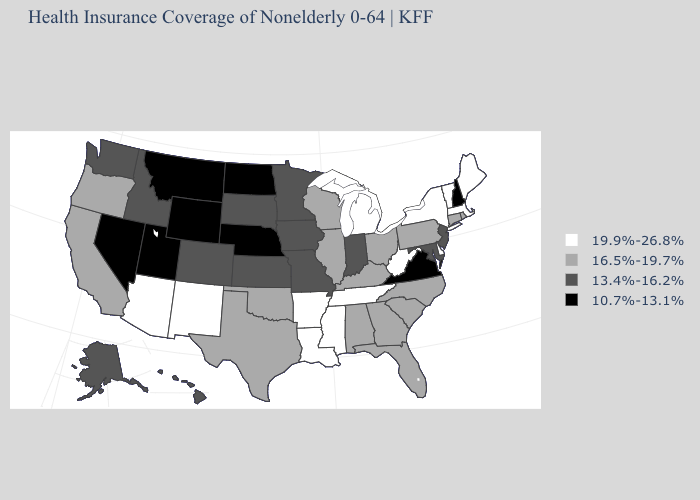What is the value of Ohio?
Write a very short answer. 16.5%-19.7%. Among the states that border Louisiana , does Arkansas have the highest value?
Short answer required. Yes. Does Kansas have the lowest value in the USA?
Answer briefly. No. What is the highest value in the USA?
Quick response, please. 19.9%-26.8%. What is the value of Virginia?
Give a very brief answer. 10.7%-13.1%. Among the states that border Massachusetts , which have the highest value?
Keep it brief. New York, Vermont. What is the value of Alabama?
Concise answer only. 16.5%-19.7%. Among the states that border Vermont , does New Hampshire have the highest value?
Short answer required. No. Among the states that border Indiana , which have the lowest value?
Give a very brief answer. Illinois, Kentucky, Ohio. Name the states that have a value in the range 16.5%-19.7%?
Concise answer only. Alabama, California, Connecticut, Florida, Georgia, Illinois, Kentucky, North Carolina, Ohio, Oklahoma, Oregon, Pennsylvania, Rhode Island, South Carolina, Texas, Wisconsin. Name the states that have a value in the range 19.9%-26.8%?
Concise answer only. Arizona, Arkansas, Delaware, Louisiana, Maine, Massachusetts, Michigan, Mississippi, New Mexico, New York, Tennessee, Vermont, West Virginia. Among the states that border South Carolina , which have the highest value?
Be succinct. Georgia, North Carolina. What is the highest value in the USA?
Answer briefly. 19.9%-26.8%. Which states have the highest value in the USA?
Be succinct. Arizona, Arkansas, Delaware, Louisiana, Maine, Massachusetts, Michigan, Mississippi, New Mexico, New York, Tennessee, Vermont, West Virginia. Is the legend a continuous bar?
Short answer required. No. 